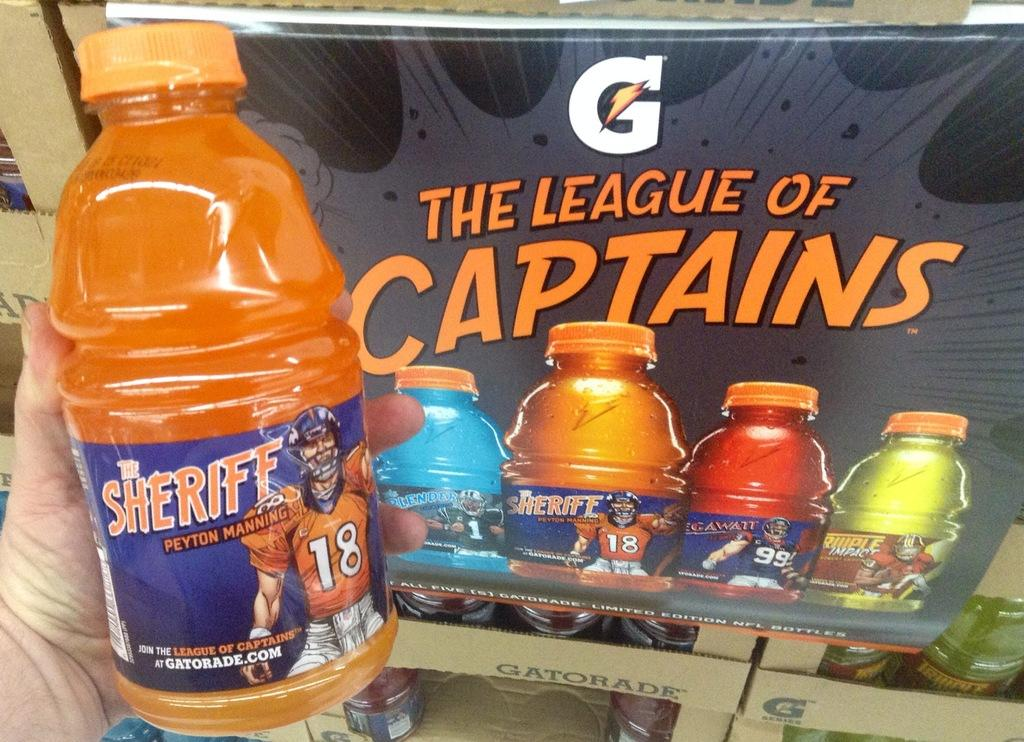<image>
Offer a succinct explanation of the picture presented. Person holding an orange Gatorade bottle with a label that says Sheriff. 